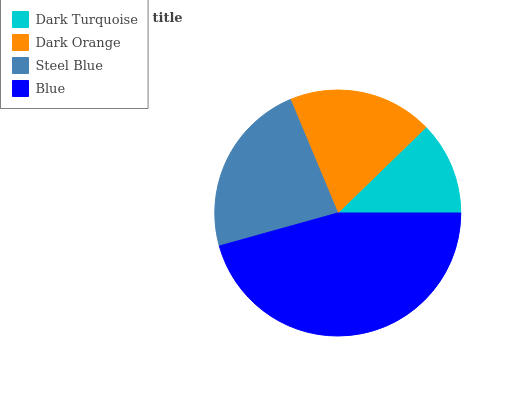Is Dark Turquoise the minimum?
Answer yes or no. Yes. Is Blue the maximum?
Answer yes or no. Yes. Is Dark Orange the minimum?
Answer yes or no. No. Is Dark Orange the maximum?
Answer yes or no. No. Is Dark Orange greater than Dark Turquoise?
Answer yes or no. Yes. Is Dark Turquoise less than Dark Orange?
Answer yes or no. Yes. Is Dark Turquoise greater than Dark Orange?
Answer yes or no. No. Is Dark Orange less than Dark Turquoise?
Answer yes or no. No. Is Steel Blue the high median?
Answer yes or no. Yes. Is Dark Orange the low median?
Answer yes or no. Yes. Is Dark Orange the high median?
Answer yes or no. No. Is Steel Blue the low median?
Answer yes or no. No. 